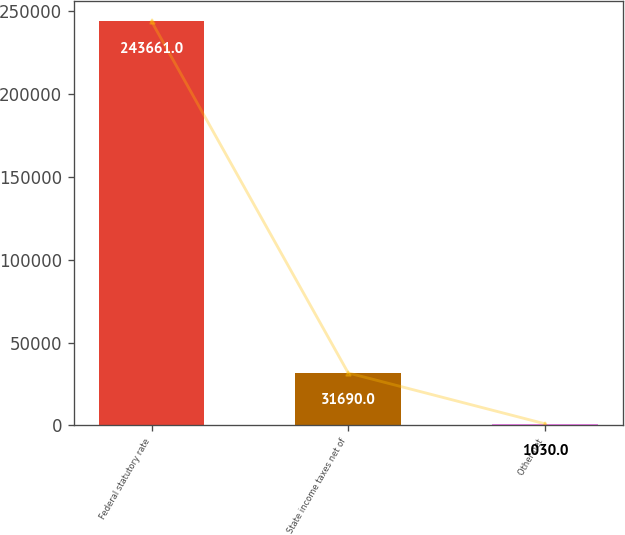<chart> <loc_0><loc_0><loc_500><loc_500><bar_chart><fcel>Federal statutory rate<fcel>State income taxes net of<fcel>Other net<nl><fcel>243661<fcel>31690<fcel>1030<nl></chart> 